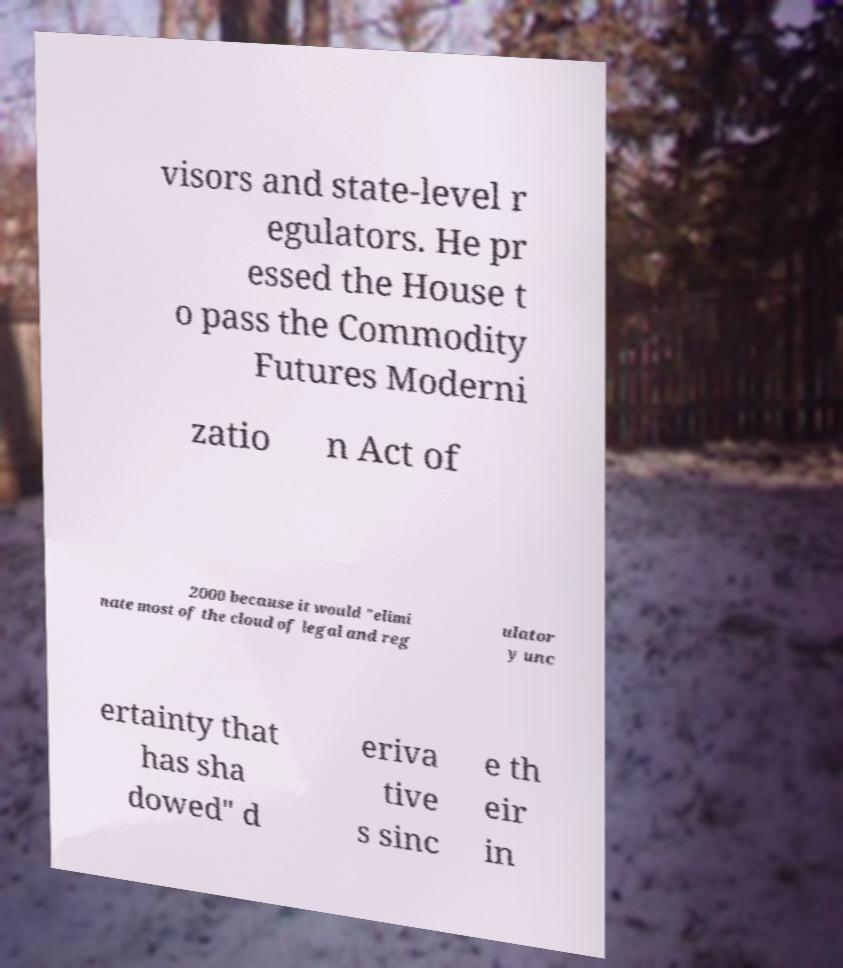Can you accurately transcribe the text from the provided image for me? visors and state-level r egulators. He pr essed the House t o pass the Commodity Futures Moderni zatio n Act of 2000 because it would "elimi nate most of the cloud of legal and reg ulator y unc ertainty that has sha dowed" d eriva tive s sinc e th eir in 